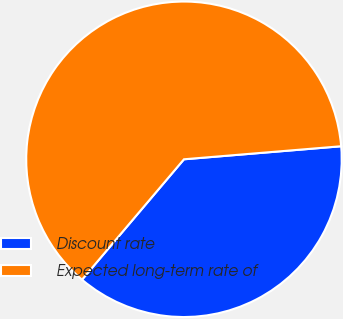Convert chart to OTSL. <chart><loc_0><loc_0><loc_500><loc_500><pie_chart><fcel>Discount rate<fcel>Expected long-term rate of<nl><fcel>37.5%<fcel>62.5%<nl></chart> 